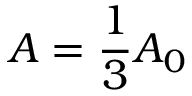<formula> <loc_0><loc_0><loc_500><loc_500>A = \frac { 1 } { 3 } A _ { 0 }</formula> 